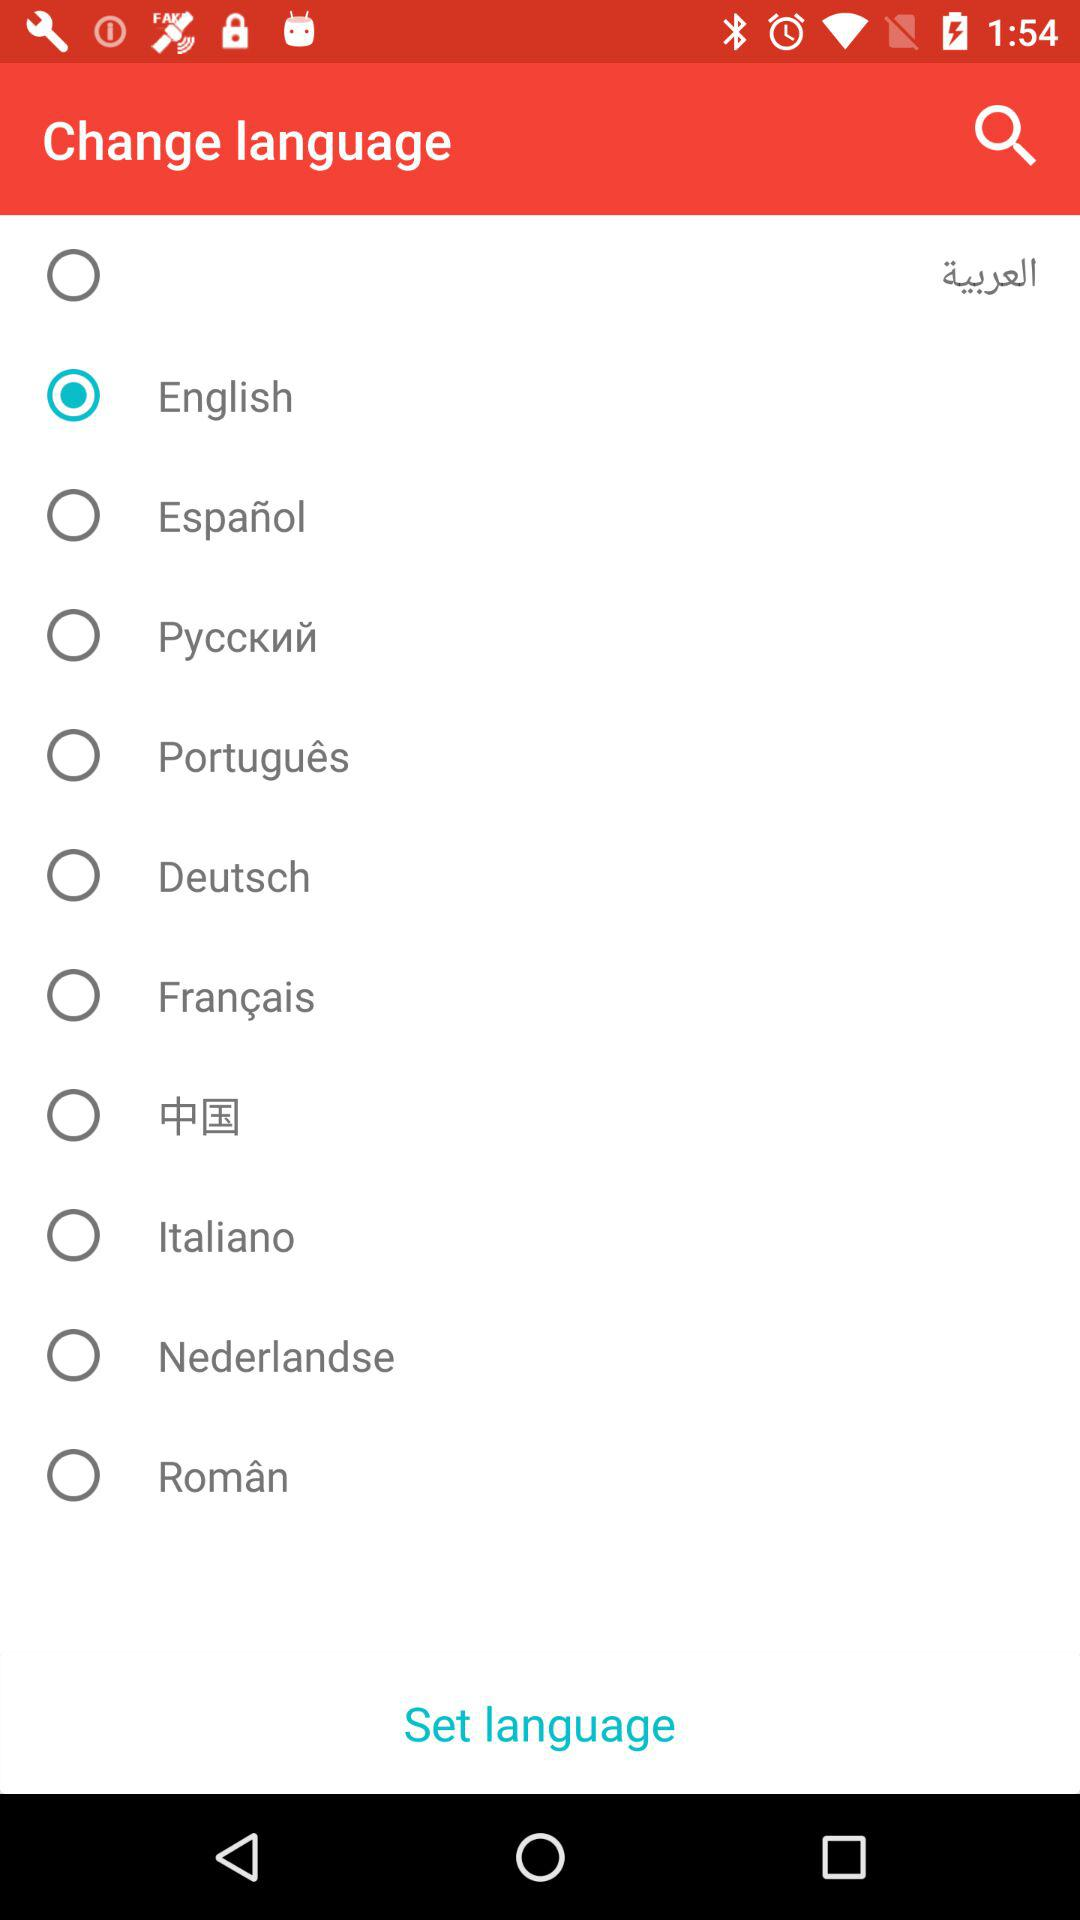Which language has been chosen? The chosen language is "English". 